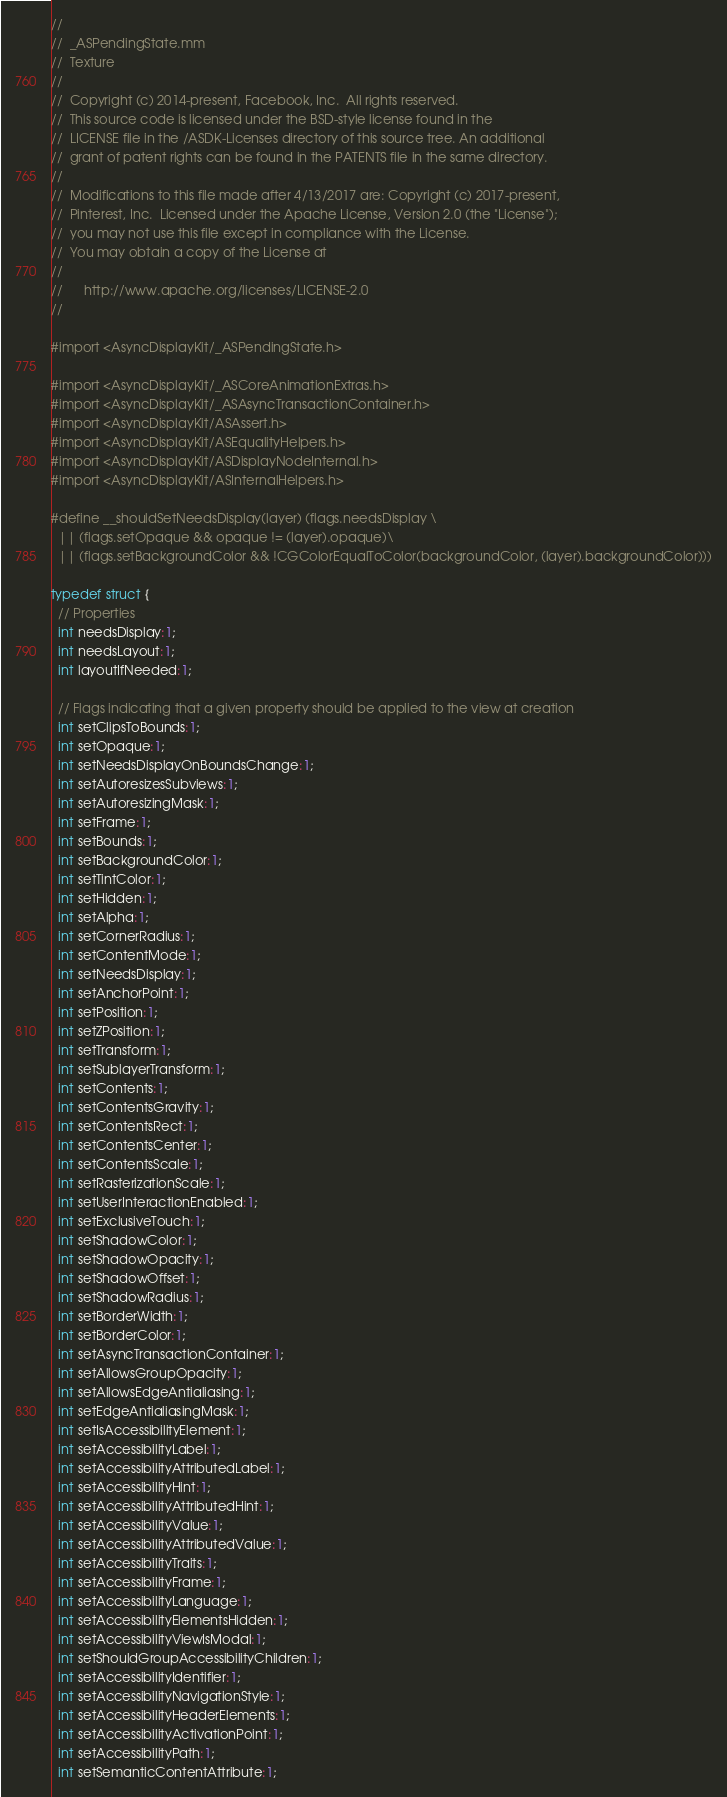Convert code to text. <code><loc_0><loc_0><loc_500><loc_500><_ObjectiveC_>//
//  _ASPendingState.mm
//  Texture
//
//  Copyright (c) 2014-present, Facebook, Inc.  All rights reserved.
//  This source code is licensed under the BSD-style license found in the
//  LICENSE file in the /ASDK-Licenses directory of this source tree. An additional
//  grant of patent rights can be found in the PATENTS file in the same directory.
//
//  Modifications to this file made after 4/13/2017 are: Copyright (c) 2017-present,
//  Pinterest, Inc.  Licensed under the Apache License, Version 2.0 (the "License");
//  you may not use this file except in compliance with the License.
//  You may obtain a copy of the License at
//
//      http://www.apache.org/licenses/LICENSE-2.0
//

#import <AsyncDisplayKit/_ASPendingState.h>

#import <AsyncDisplayKit/_ASCoreAnimationExtras.h>
#import <AsyncDisplayKit/_ASAsyncTransactionContainer.h>
#import <AsyncDisplayKit/ASAssert.h>
#import <AsyncDisplayKit/ASEqualityHelpers.h>
#import <AsyncDisplayKit/ASDisplayNodeInternal.h>
#import <AsyncDisplayKit/ASInternalHelpers.h>

#define __shouldSetNeedsDisplay(layer) (flags.needsDisplay \
  || (flags.setOpaque && opaque != (layer).opaque)\
  || (flags.setBackgroundColor && !CGColorEqualToColor(backgroundColor, (layer).backgroundColor)))

typedef struct {
  // Properties
  int needsDisplay:1;
  int needsLayout:1;
  int layoutIfNeeded:1;
  
  // Flags indicating that a given property should be applied to the view at creation
  int setClipsToBounds:1;
  int setOpaque:1;
  int setNeedsDisplayOnBoundsChange:1;
  int setAutoresizesSubviews:1;
  int setAutoresizingMask:1;
  int setFrame:1;
  int setBounds:1;
  int setBackgroundColor:1;
  int setTintColor:1;
  int setHidden:1;
  int setAlpha:1;
  int setCornerRadius:1;
  int setContentMode:1;
  int setNeedsDisplay:1;
  int setAnchorPoint:1;
  int setPosition:1;
  int setZPosition:1;
  int setTransform:1;
  int setSublayerTransform:1;
  int setContents:1;
  int setContentsGravity:1;
  int setContentsRect:1;
  int setContentsCenter:1;
  int setContentsScale:1;
  int setRasterizationScale:1;
  int setUserInteractionEnabled:1;
  int setExclusiveTouch:1;
  int setShadowColor:1;
  int setShadowOpacity:1;
  int setShadowOffset:1;
  int setShadowRadius:1;
  int setBorderWidth:1;
  int setBorderColor:1;
  int setAsyncTransactionContainer:1;
  int setAllowsGroupOpacity:1;
  int setAllowsEdgeAntialiasing:1;
  int setEdgeAntialiasingMask:1;
  int setIsAccessibilityElement:1;
  int setAccessibilityLabel:1;
  int setAccessibilityAttributedLabel:1;
  int setAccessibilityHint:1;
  int setAccessibilityAttributedHint:1;
  int setAccessibilityValue:1;
  int setAccessibilityAttributedValue:1;
  int setAccessibilityTraits:1;
  int setAccessibilityFrame:1;
  int setAccessibilityLanguage:1;
  int setAccessibilityElementsHidden:1;
  int setAccessibilityViewIsModal:1;
  int setShouldGroupAccessibilityChildren:1;
  int setAccessibilityIdentifier:1;
  int setAccessibilityNavigationStyle:1;
  int setAccessibilityHeaderElements:1;
  int setAccessibilityActivationPoint:1;
  int setAccessibilityPath:1;
  int setSemanticContentAttribute:1;</code> 